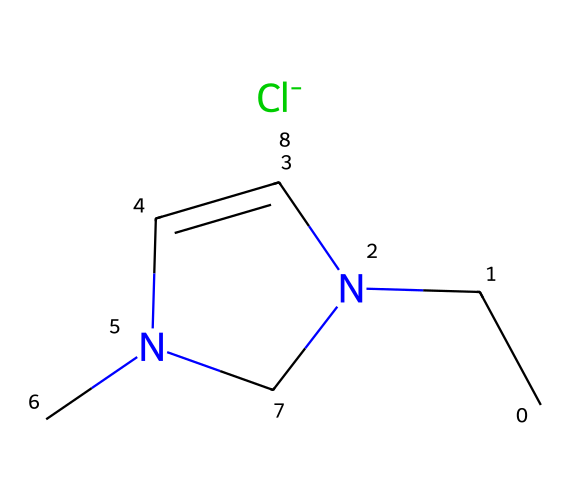What is the total number of carbon atoms in the structure? By examining the SMILES notation, we can identify the carbon atoms: there are two carbon atoms from the ethyl group (CC) and one from the imidazolium ring (N1C=CN), resulting in a total of three carbon atoms.
Answer: 3 How many nitrogen atoms are present in the chemical structure? In the SMILES representation, the nitrogen atoms can be counted from the imidazolium ring, which has two nitrogen atoms listed as "N". Thus, the total number of nitrogen atoms in the structure is two.
Answer: 2 What type of ion does this ionic liquid contain? The chloride ion is represented at the end of the SMILES notation as "[Cl-]", indicating that the ionic liquid contains a chloride ion, which is essential for imparting ionic properties to the compound.
Answer: chloride What is the molecular weight of 1-ethyl-3-methylimidazolium chloride? To determine the molecular weight, we can look at the atomic masses: Carbon (C) = 12.01, Hydrogen (H) = 1.008, Nitrogen (N) = 14.01, and Chlorine (Cl) = 35.45. This calculation results in a total molecular weight of approximately 138.57 g/mol.
Answer: 138.57 What makes 1-ethyl-3-methylimidazolium chloride an ionic liquid? This compound qualifies as an ionic liquid because it consists of a symmetrical cation (1-ethyl-3-methylimidazolium) and an anion (chloride), resulting in a low melting point and liquid at room temperature, characteristic of ionic liquids.
Answer: low melting point How does the structure of this ionic liquid affect its solubility properties? The presence of both polar (from the imidazolium cation) and non-polar components (from the ethyl and methyl groups) allows for enhanced solubility in various solvents, particularly ionic and polar solvents, thus affecting its behavior in applications such as military gear cleaning.
Answer: enhances solubility What role does the imidazolium ring play in the ionic liquid’s properties? The imidazolium ring contains nitrogen atoms that contribute to the charge distribution and stabilization of the ionic liquid, affecting properties such as viscosity and ionic conductivity, which are critical for its performance in applications.
Answer: charge stabilization 